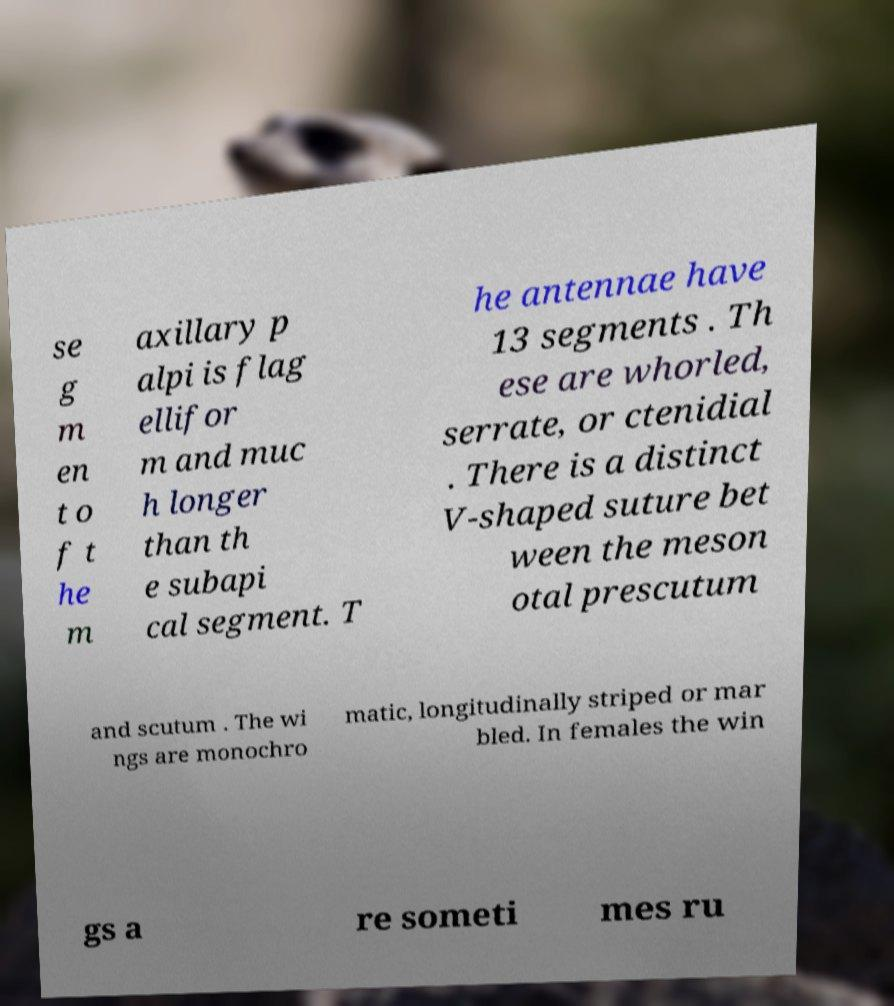I need the written content from this picture converted into text. Can you do that? se g m en t o f t he m axillary p alpi is flag ellifor m and muc h longer than th e subapi cal segment. T he antennae have 13 segments . Th ese are whorled, serrate, or ctenidial . There is a distinct V-shaped suture bet ween the meson otal prescutum and scutum . The wi ngs are monochro matic, longitudinally striped or mar bled. In females the win gs a re someti mes ru 